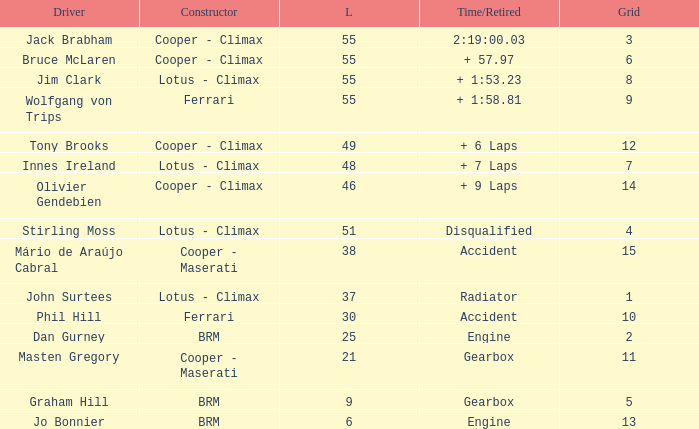Tell me the laps for 3 grids 55.0. 